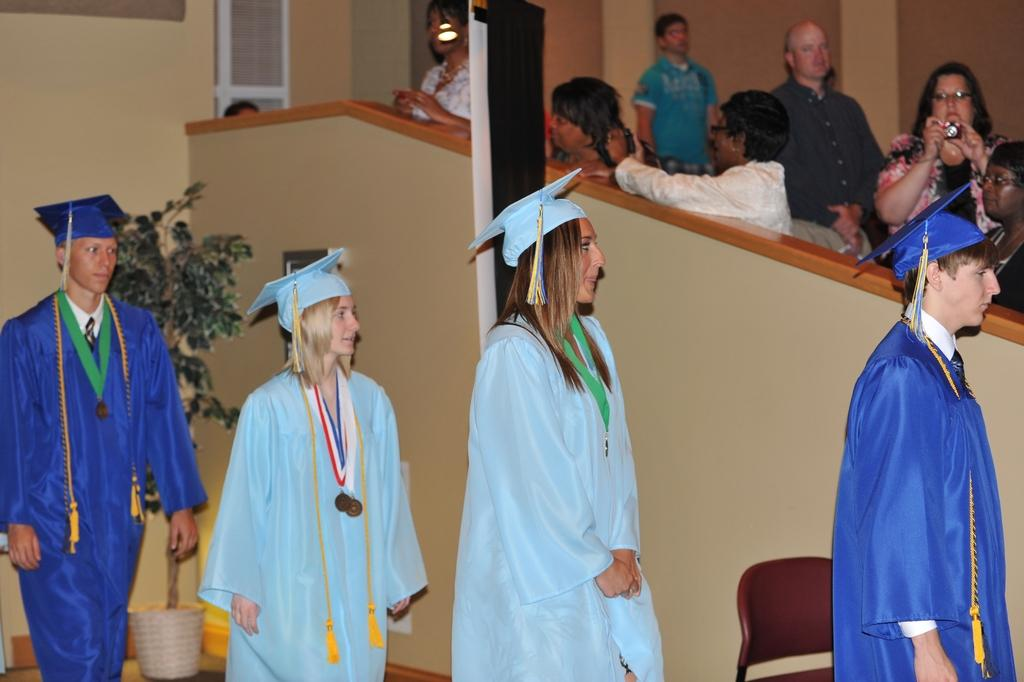What is happening in the image? There are four persons standing in the image. What are the four persons wearing? The four persons are wearing convocation dress. Can you describe the background of the image? There are other persons in the background of the image. What type of ring can be seen on the corn in the image? There is no corn or ring present in the image; it features four persons wearing convocation dress. 